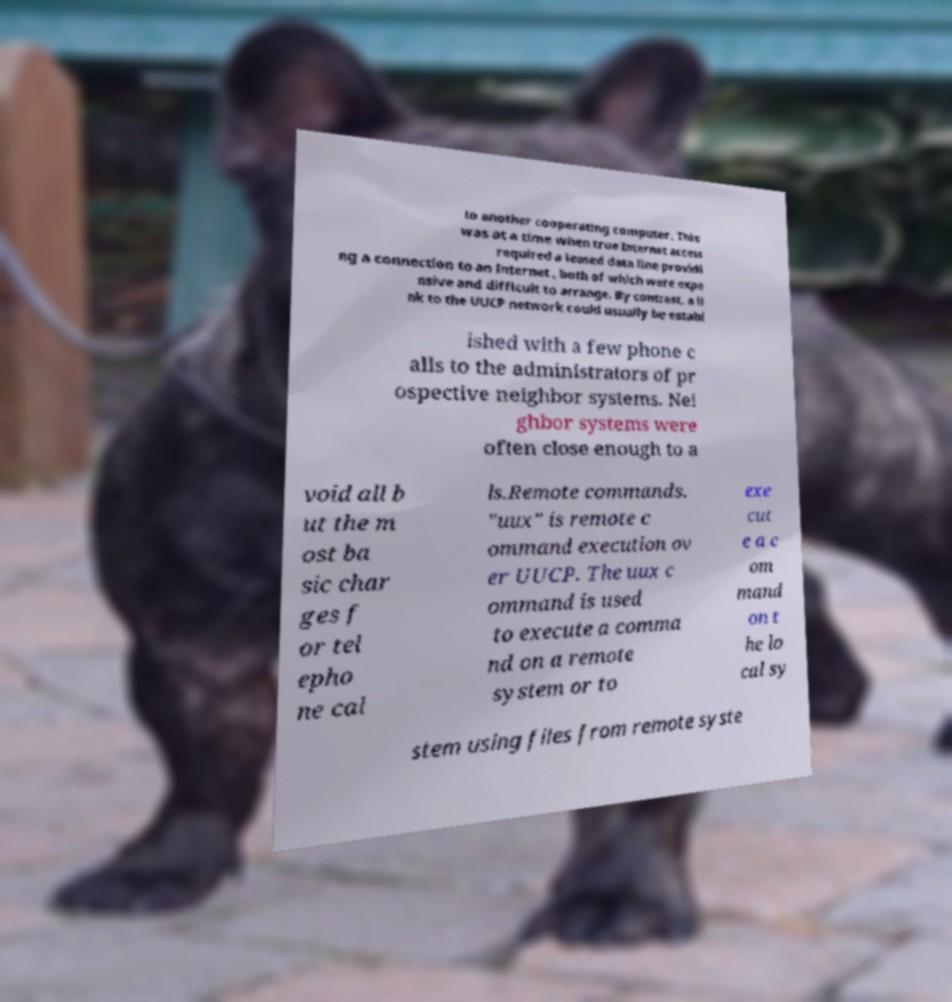Could you extract and type out the text from this image? to another cooperating computer. This was at a time when true Internet access required a leased data line providi ng a connection to an Internet , both of which were expe nsive and difficult to arrange. By contrast, a li nk to the UUCP network could usually be establ ished with a few phone c alls to the administrators of pr ospective neighbor systems. Nei ghbor systems were often close enough to a void all b ut the m ost ba sic char ges f or tel epho ne cal ls.Remote commands. "uux" is remote c ommand execution ov er UUCP. The uux c ommand is used to execute a comma nd on a remote system or to exe cut e a c om mand on t he lo cal sy stem using files from remote syste 